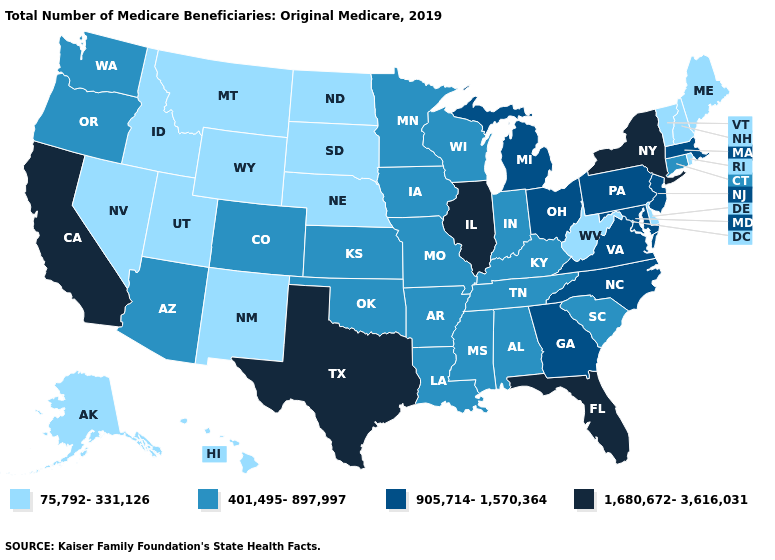Does Tennessee have a higher value than Utah?
Concise answer only. Yes. Does the map have missing data?
Be succinct. No. What is the value of Kansas?
Answer briefly. 401,495-897,997. Name the states that have a value in the range 75,792-331,126?
Answer briefly. Alaska, Delaware, Hawaii, Idaho, Maine, Montana, Nebraska, Nevada, New Hampshire, New Mexico, North Dakota, Rhode Island, South Dakota, Utah, Vermont, West Virginia, Wyoming. Which states have the lowest value in the USA?
Be succinct. Alaska, Delaware, Hawaii, Idaho, Maine, Montana, Nebraska, Nevada, New Hampshire, New Mexico, North Dakota, Rhode Island, South Dakota, Utah, Vermont, West Virginia, Wyoming. Does the map have missing data?
Keep it brief. No. Name the states that have a value in the range 75,792-331,126?
Write a very short answer. Alaska, Delaware, Hawaii, Idaho, Maine, Montana, Nebraska, Nevada, New Hampshire, New Mexico, North Dakota, Rhode Island, South Dakota, Utah, Vermont, West Virginia, Wyoming. What is the lowest value in the USA?
Concise answer only. 75,792-331,126. Among the states that border Mississippi , which have the highest value?
Keep it brief. Alabama, Arkansas, Louisiana, Tennessee. What is the value of Georgia?
Concise answer only. 905,714-1,570,364. What is the lowest value in the USA?
Write a very short answer. 75,792-331,126. Among the states that border New York , does New Jersey have the highest value?
Quick response, please. Yes. Name the states that have a value in the range 1,680,672-3,616,031?
Be succinct. California, Florida, Illinois, New York, Texas. Name the states that have a value in the range 75,792-331,126?
Write a very short answer. Alaska, Delaware, Hawaii, Idaho, Maine, Montana, Nebraska, Nevada, New Hampshire, New Mexico, North Dakota, Rhode Island, South Dakota, Utah, Vermont, West Virginia, Wyoming. 